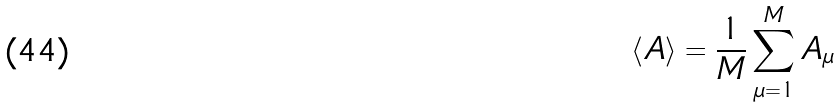Convert formula to latex. <formula><loc_0><loc_0><loc_500><loc_500>\langle A \rangle = \frac { 1 } { M } \sum _ { \mu = 1 } ^ { M } A _ { \mu }</formula> 